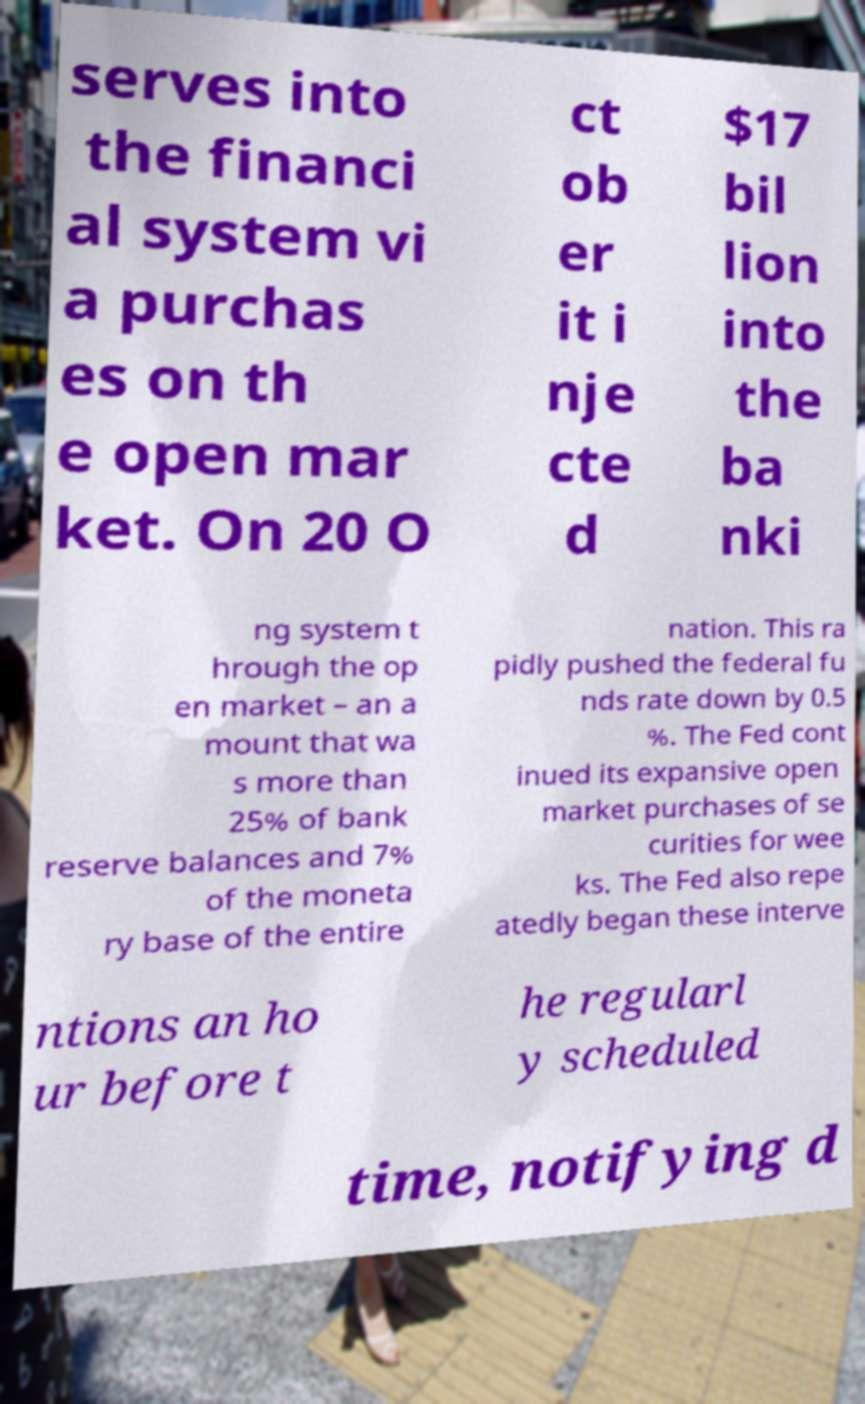For documentation purposes, I need the text within this image transcribed. Could you provide that? serves into the financi al system vi a purchas es on th e open mar ket. On 20 O ct ob er it i nje cte d $17 bil lion into the ba nki ng system t hrough the op en market – an a mount that wa s more than 25% of bank reserve balances and 7% of the moneta ry base of the entire nation. This ra pidly pushed the federal fu nds rate down by 0.5 %. The Fed cont inued its expansive open market purchases of se curities for wee ks. The Fed also repe atedly began these interve ntions an ho ur before t he regularl y scheduled time, notifying d 